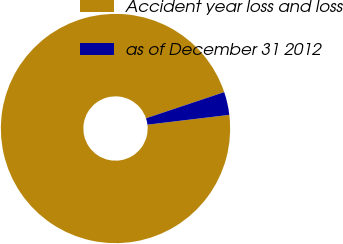Convert chart. <chart><loc_0><loc_0><loc_500><loc_500><pie_chart><fcel>Accident year loss and loss<fcel>as of December 31 2012<nl><fcel>96.76%<fcel>3.24%<nl></chart> 